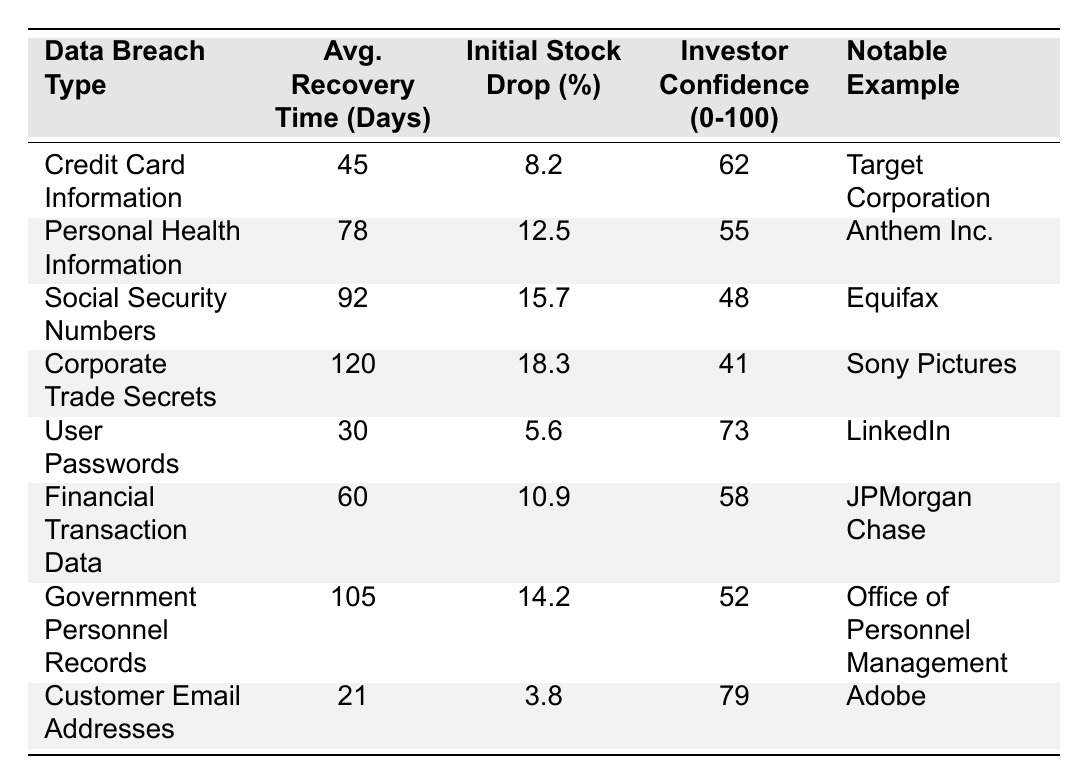What is the average market recovery time for data breaches involving user passwords? From the table, the market recovery time for user passwords is clearly listed as 30 days.
Answer: 30 days Which data breach type has the longest average market recovery time? The data shows that "Corporate Trade Secrets" has the longest average recovery time at 120 days.
Answer: 120 days What is the initial stock price drop percentage for the "Social Security Numbers" data breach type? According to the table, the initial stock price drop for "Social Security Numbers" is 15.7%.
Answer: 15.7% How does the investor confidence index compare between "Credit Card Information" and "User Passwords"? "Credit Card Information" has an investor confidence index of 62, while "User Passwords" has an index of 73. Therefore, "User Passwords" has a higher confidence index.
Answer: User Passwords has a higher confidence index What is the total initial stock price drop percentage for all data breaches? To find the total, we add all the initial stock drops: 8.2 + 12.5 + 15.7 + 18.3 + 5.6 + 10.9 + 14.2 + 3.8 = 89.2%.
Answer: 89.2% Is the average market recovery time for "Personal Health Information" greater than that for "Financial Transaction Data"? The average market recovery time for "Personal Health Information" is 78 days, and for "Financial Transaction Data" it is 60 days, confirming that the former is greater.
Answer: Yes What is the average investor confidence index for data breaches associated with financial data types? The financial data breaches are "Financial Transaction Data" (58) and "Credit Card Information" (62). Average is (58 + 62) / 2 = 60.
Answer: 60 Which notable company example has the lowest investor confidence index? The table indicates that "Equifax," related to "Social Security Numbers," has the lowest investor confidence index at 48.
Answer: Equifax What is the median average market recovery time among the listed data breach types? Ordering the recovery times: 21, 30, 45, 60, 78, 92, 105, 120. The median (4th and 5th values) is (60 + 78) / 2 = 69.
Answer: 69 What percentage drop is observed for customer email addresses? The table states that the initial stock price drop for customer email addresses is 3.8%.
Answer: 3.8% Which data breach type has an average recovery time shorter than 60 days? "User Passwords" (30 days) and "Credit Card Information" (45 days) both have recovery times shorter than 60 days, as shown in the table.
Answer: User Passwords and Credit Card Information 